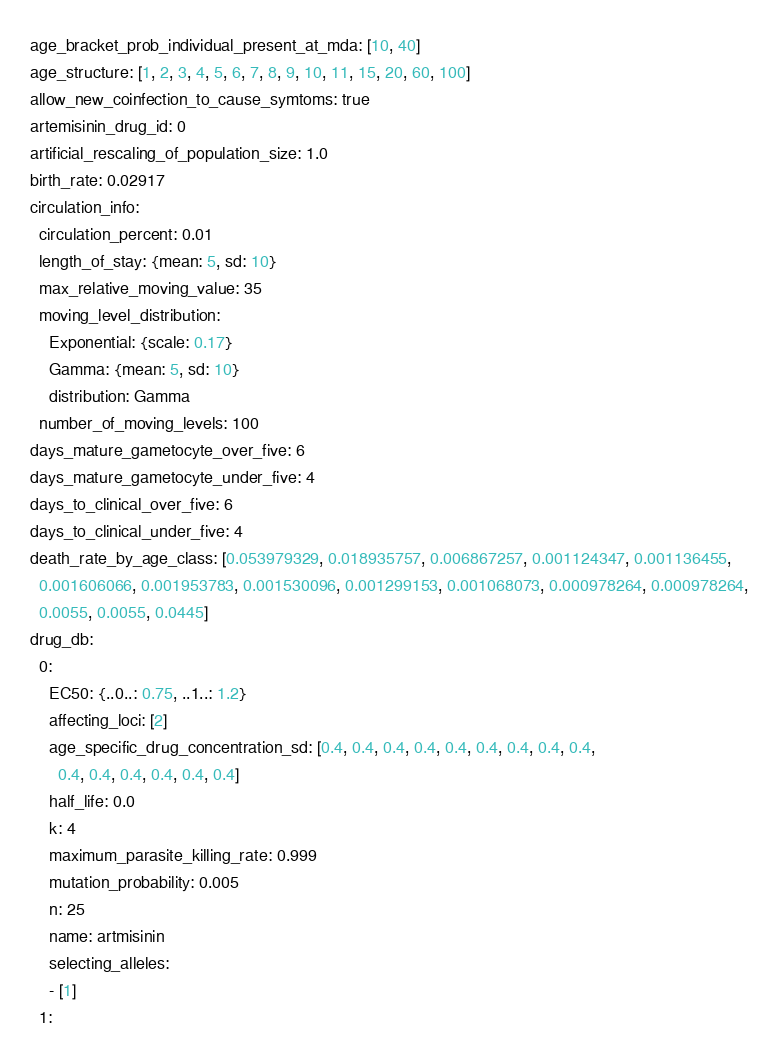<code> <loc_0><loc_0><loc_500><loc_500><_YAML_>age_bracket_prob_individual_present_at_mda: [10, 40]
age_structure: [1, 2, 3, 4, 5, 6, 7, 8, 9, 10, 11, 15, 20, 60, 100]
allow_new_coinfection_to_cause_symtoms: true
artemisinin_drug_id: 0
artificial_rescaling_of_population_size: 1.0
birth_rate: 0.02917
circulation_info:
  circulation_percent: 0.01
  length_of_stay: {mean: 5, sd: 10}
  max_relative_moving_value: 35
  moving_level_distribution:
    Exponential: {scale: 0.17}
    Gamma: {mean: 5, sd: 10}
    distribution: Gamma
  number_of_moving_levels: 100
days_mature_gametocyte_over_five: 6
days_mature_gametocyte_under_five: 4
days_to_clinical_over_five: 6
days_to_clinical_under_five: 4
death_rate_by_age_class: [0.053979329, 0.018935757, 0.006867257, 0.001124347, 0.001136455,
  0.001606066, 0.001953783, 0.001530096, 0.001299153, 0.001068073, 0.000978264, 0.000978264,
  0.0055, 0.0055, 0.0445]
drug_db:
  0:
    EC50: {..0..: 0.75, ..1..: 1.2}
    affecting_loci: [2]
    age_specific_drug_concentration_sd: [0.4, 0.4, 0.4, 0.4, 0.4, 0.4, 0.4, 0.4, 0.4,
      0.4, 0.4, 0.4, 0.4, 0.4, 0.4]
    half_life: 0.0
    k: 4
    maximum_parasite_killing_rate: 0.999
    mutation_probability: 0.005
    n: 25
    name: artmisinin
    selecting_alleles:
    - [1]
  1:</code> 